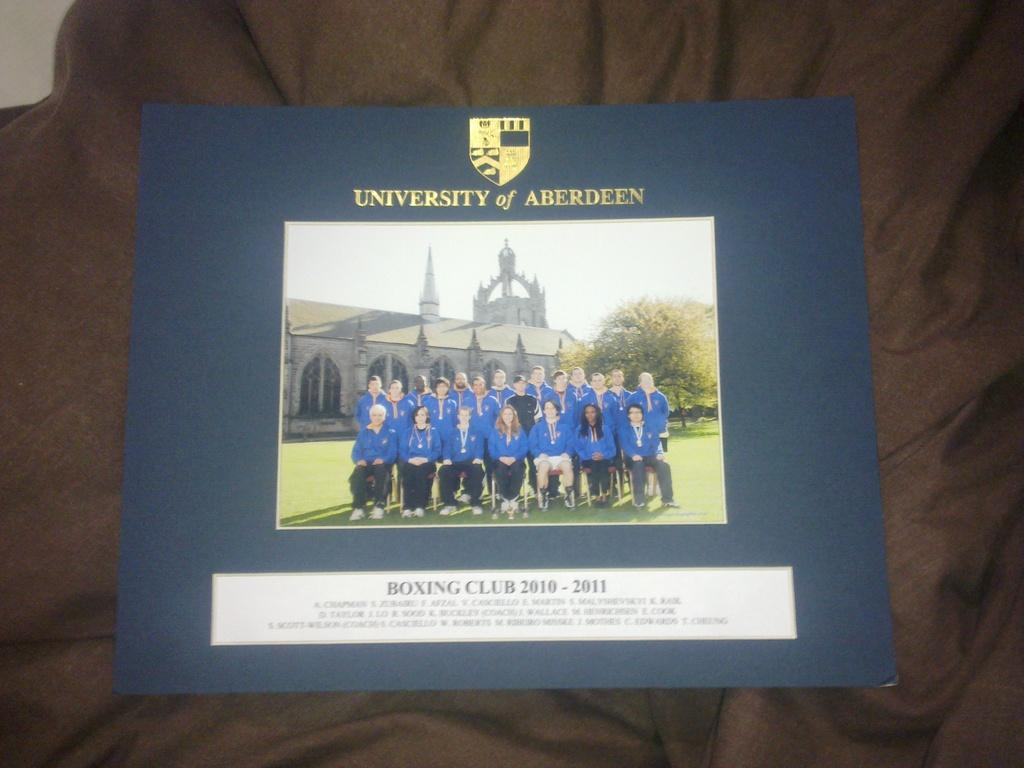Provide a one-sentence caption for the provided image. A picture of the university of aberdeens' Boxing club. 